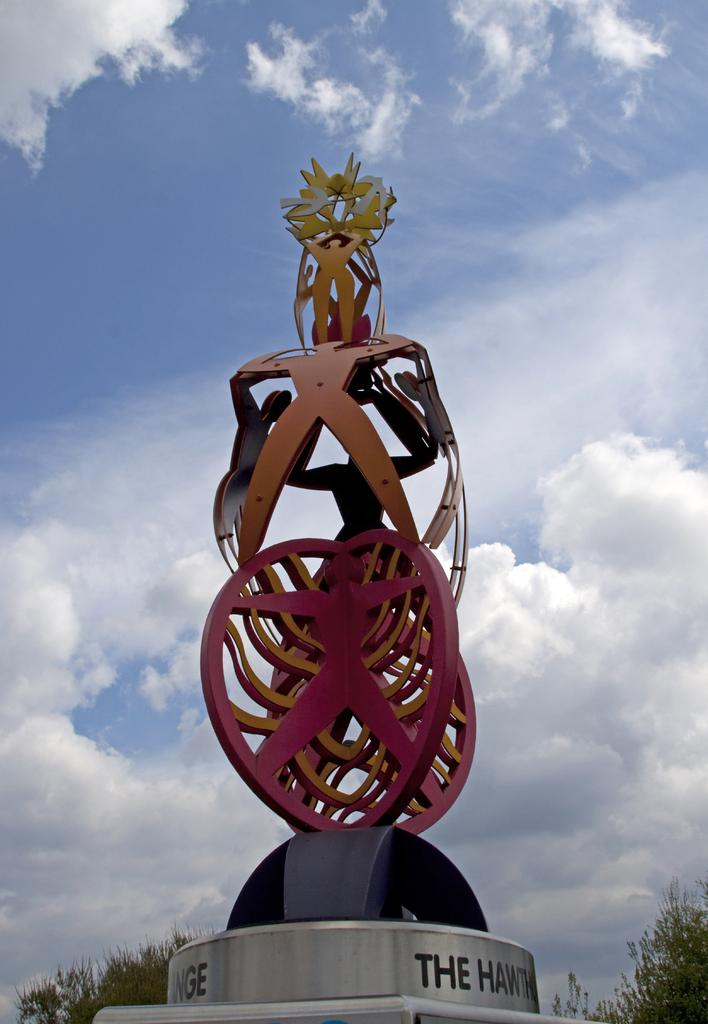What is the main subject in the image? There is a sculpture in the image. What can be seen in the background of the image? There are trees and the sky visible in the background of the image. What is the condition of the sky in the image? Clouds are present in the sky. How many bikes are leaning against the sculpture in the image? There are no bikes present in the image; it features a sculpture with trees and clouds in the background. What level of comfort does the sculpture provide in the image? The sculpture is an inanimate object and cannot provide comfort. 